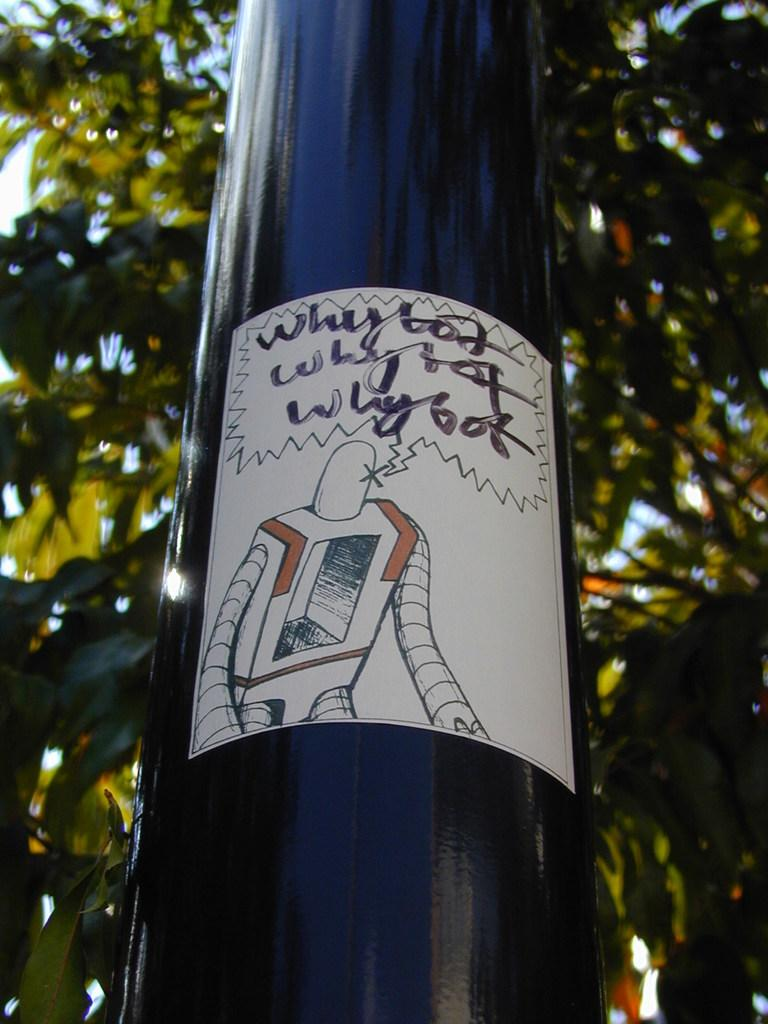<image>
Present a compact description of the photo's key features. A sticker on a pole that says Why bot 3 times 